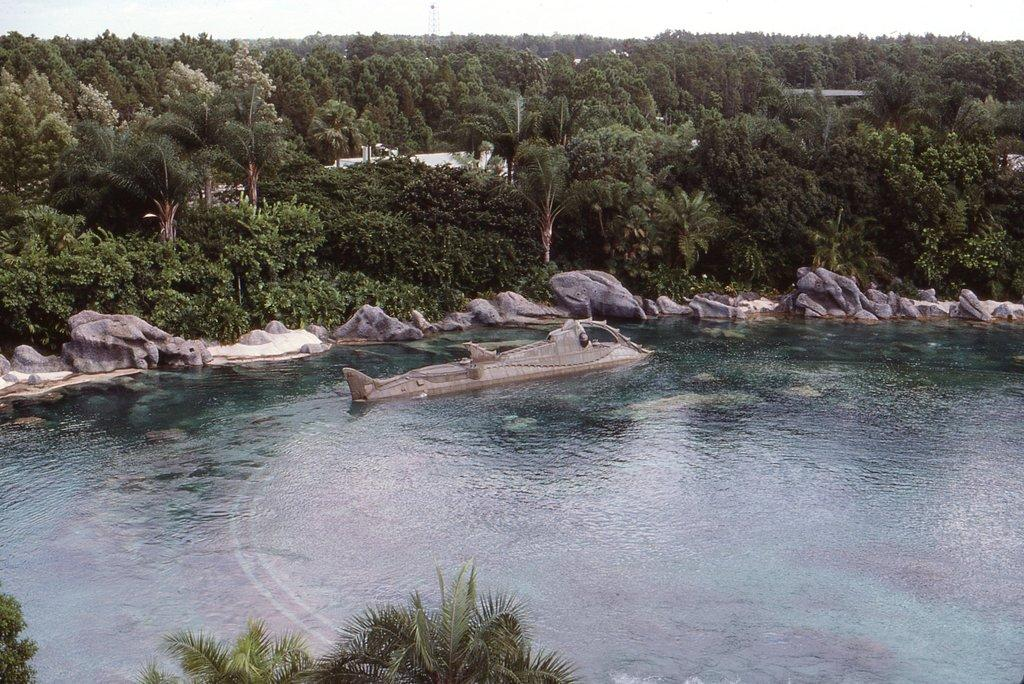What body of water is present in the image? There is a lake in the image. What is in the lake? There appears to be a ship in the lake. What type of natural features can be seen in the image? Rocks, trees, and plants are visible in the image. What type of man-made structures are present in the image? There are houses in the image. Where are the trees located in the image? Trees are present at the bottom of the image. What committee is responsible for the motion of the ship in the image? There is no committee mentioned in the image, and the motion of the ship is not relevant to the provided facts. 